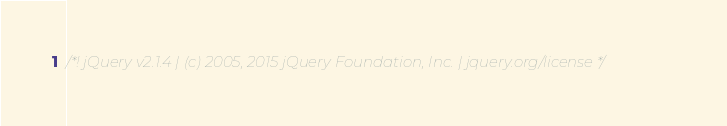Convert code to text. <code><loc_0><loc_0><loc_500><loc_500><_JavaScript_>/*! jQuery v2.1.4 | (c) 2005, 2015 jQuery Foundation, Inc. | jquery.org/license */</code> 